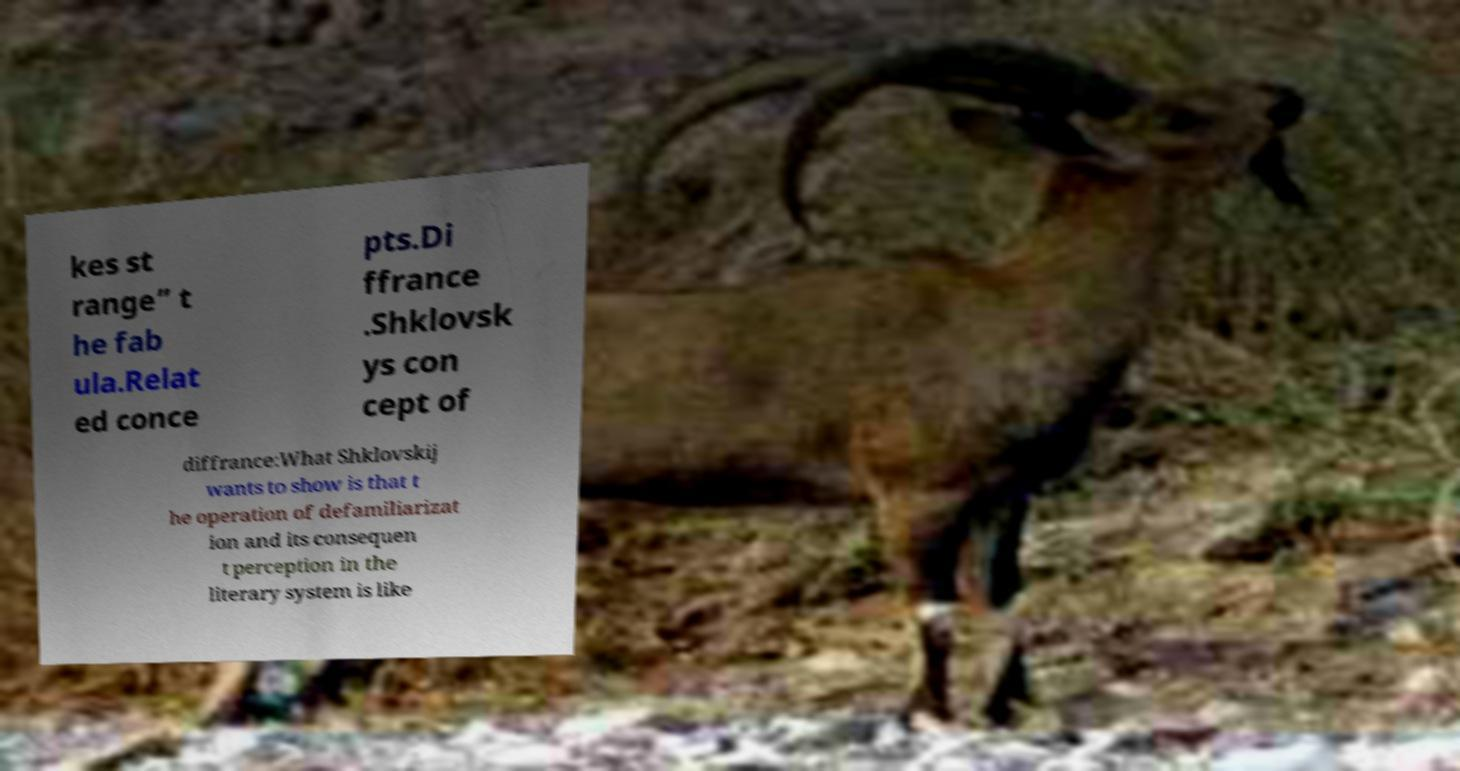Can you accurately transcribe the text from the provided image for me? kes st range” t he fab ula.Relat ed conce pts.Di ffrance .Shklovsk ys con cept of diffrance:What Shklovskij wants to show is that t he operation of defamiliarizat ion and its consequen t perception in the literary system is like 